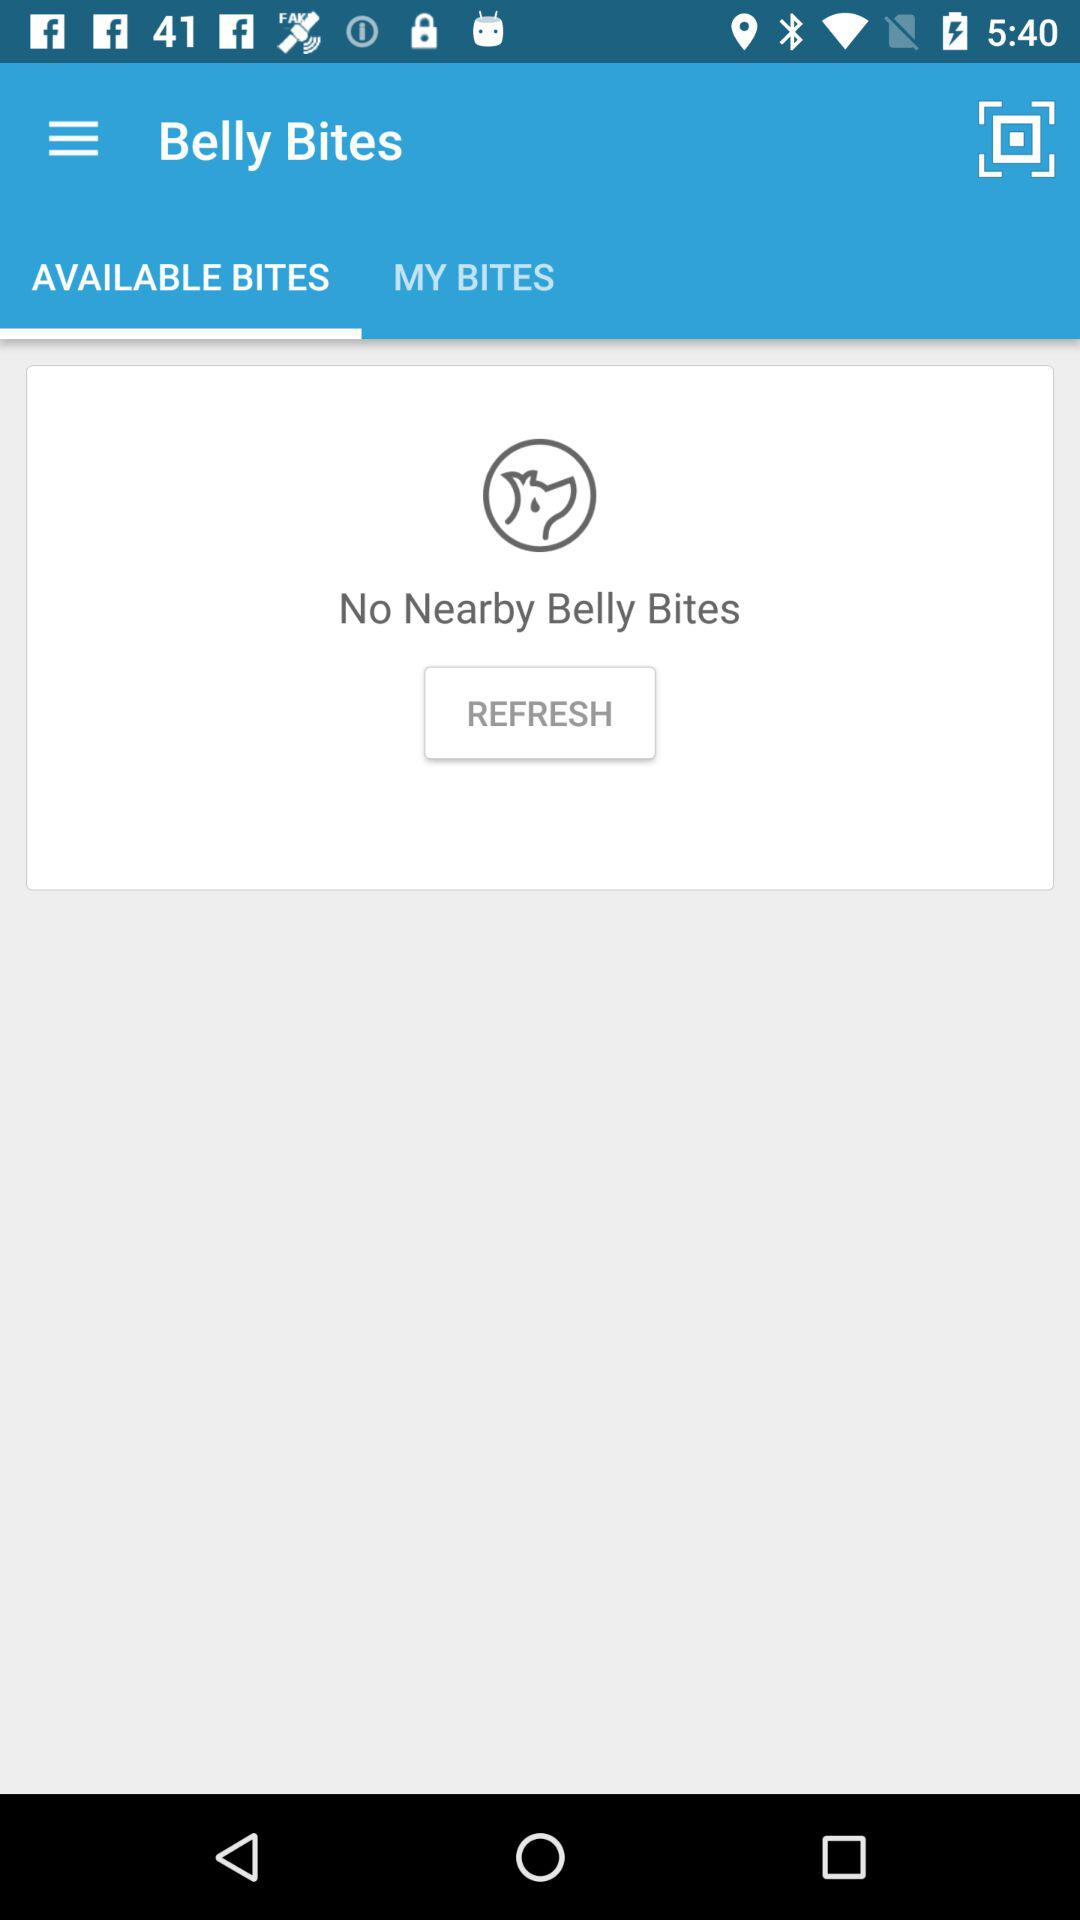Are there any nearby belly bites? There is not any nearby belly bites. 